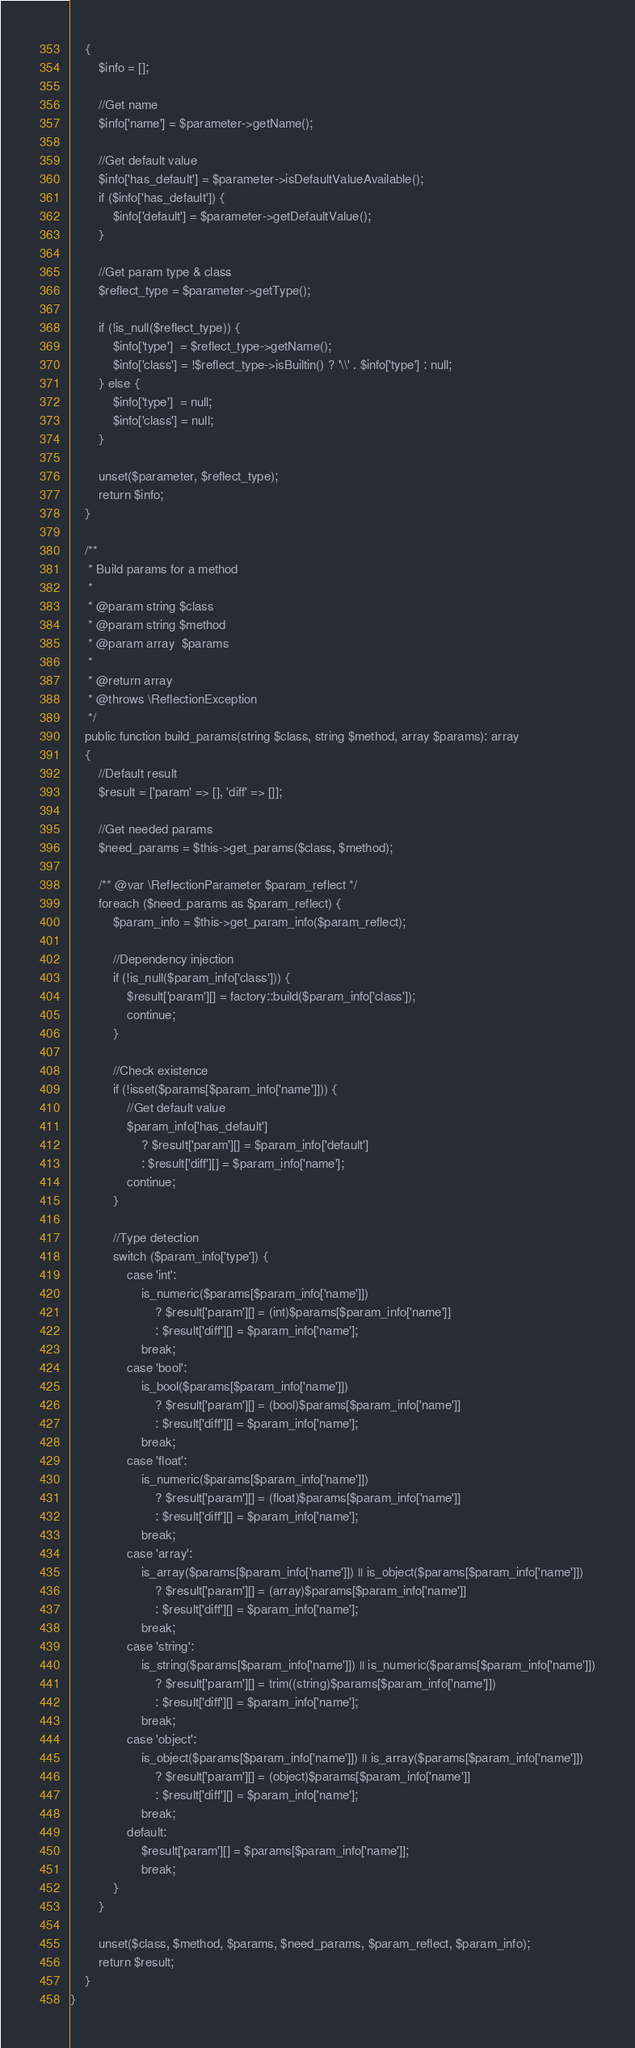Convert code to text. <code><loc_0><loc_0><loc_500><loc_500><_PHP_>    {
        $info = [];

        //Get name
        $info['name'] = $parameter->getName();

        //Get default value
        $info['has_default'] = $parameter->isDefaultValueAvailable();
        if ($info['has_default']) {
            $info['default'] = $parameter->getDefaultValue();
        }

        //Get param type & class
        $reflect_type = $parameter->getType();

        if (!is_null($reflect_type)) {
            $info['type']  = $reflect_type->getName();
            $info['class'] = !$reflect_type->isBuiltin() ? '\\' . $info['type'] : null;
        } else {
            $info['type']  = null;
            $info['class'] = null;
        }

        unset($parameter, $reflect_type);
        return $info;
    }

    /**
     * Build params for a method
     *
     * @param string $class
     * @param string $method
     * @param array  $params
     *
     * @return array
     * @throws \ReflectionException
     */
    public function build_params(string $class, string $method, array $params): array
    {
        //Default result
        $result = ['param' => [], 'diff' => []];

        //Get needed params
        $need_params = $this->get_params($class, $method);

        /** @var \ReflectionParameter $param_reflect */
        foreach ($need_params as $param_reflect) {
            $param_info = $this->get_param_info($param_reflect);

            //Dependency injection
            if (!is_null($param_info['class'])) {
                $result['param'][] = factory::build($param_info['class']);
                continue;
            }

            //Check existence
            if (!isset($params[$param_info['name']])) {
                //Get default value
                $param_info['has_default']
                    ? $result['param'][] = $param_info['default']
                    : $result['diff'][] = $param_info['name'];
                continue;
            }

            //Type detection
            switch ($param_info['type']) {
                case 'int':
                    is_numeric($params[$param_info['name']])
                        ? $result['param'][] = (int)$params[$param_info['name']]
                        : $result['diff'][] = $param_info['name'];
                    break;
                case 'bool':
                    is_bool($params[$param_info['name']])
                        ? $result['param'][] = (bool)$params[$param_info['name']]
                        : $result['diff'][] = $param_info['name'];
                    break;
                case 'float':
                    is_numeric($params[$param_info['name']])
                        ? $result['param'][] = (float)$params[$param_info['name']]
                        : $result['diff'][] = $param_info['name'];
                    break;
                case 'array':
                    is_array($params[$param_info['name']]) || is_object($params[$param_info['name']])
                        ? $result['param'][] = (array)$params[$param_info['name']]
                        : $result['diff'][] = $param_info['name'];
                    break;
                case 'string':
                    is_string($params[$param_info['name']]) || is_numeric($params[$param_info['name']])
                        ? $result['param'][] = trim((string)$params[$param_info['name']])
                        : $result['diff'][] = $param_info['name'];
                    break;
                case 'object':
                    is_object($params[$param_info['name']]) || is_array($params[$param_info['name']])
                        ? $result['param'][] = (object)$params[$param_info['name']]
                        : $result['diff'][] = $param_info['name'];
                    break;
                default:
                    $result['param'][] = $params[$param_info['name']];
                    break;
            }
        }

        unset($class, $method, $params, $need_params, $param_reflect, $param_info);
        return $result;
    }
}</code> 